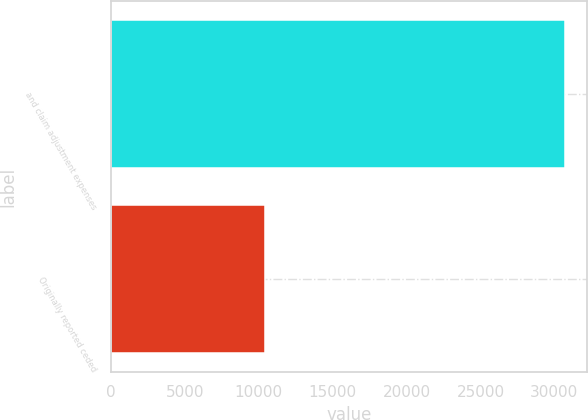Convert chart to OTSL. <chart><loc_0><loc_0><loc_500><loc_500><bar_chart><fcel>and claim adjustment expenses<fcel>Originally reported ceded<nl><fcel>30694<fcel>10438<nl></chart> 